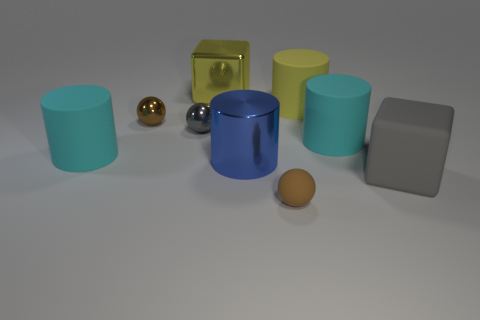Subtract 1 cylinders. How many cylinders are left? 3 Subtract all matte cylinders. How many cylinders are left? 1 Subtract all red cylinders. Subtract all blue blocks. How many cylinders are left? 4 Add 1 large rubber cylinders. How many objects exist? 10 Subtract all cylinders. How many objects are left? 5 Add 1 small gray objects. How many small gray objects are left? 2 Add 4 green rubber spheres. How many green rubber spheres exist? 4 Subtract 1 cyan cylinders. How many objects are left? 8 Subtract all big brown rubber things. Subtract all yellow metal blocks. How many objects are left? 8 